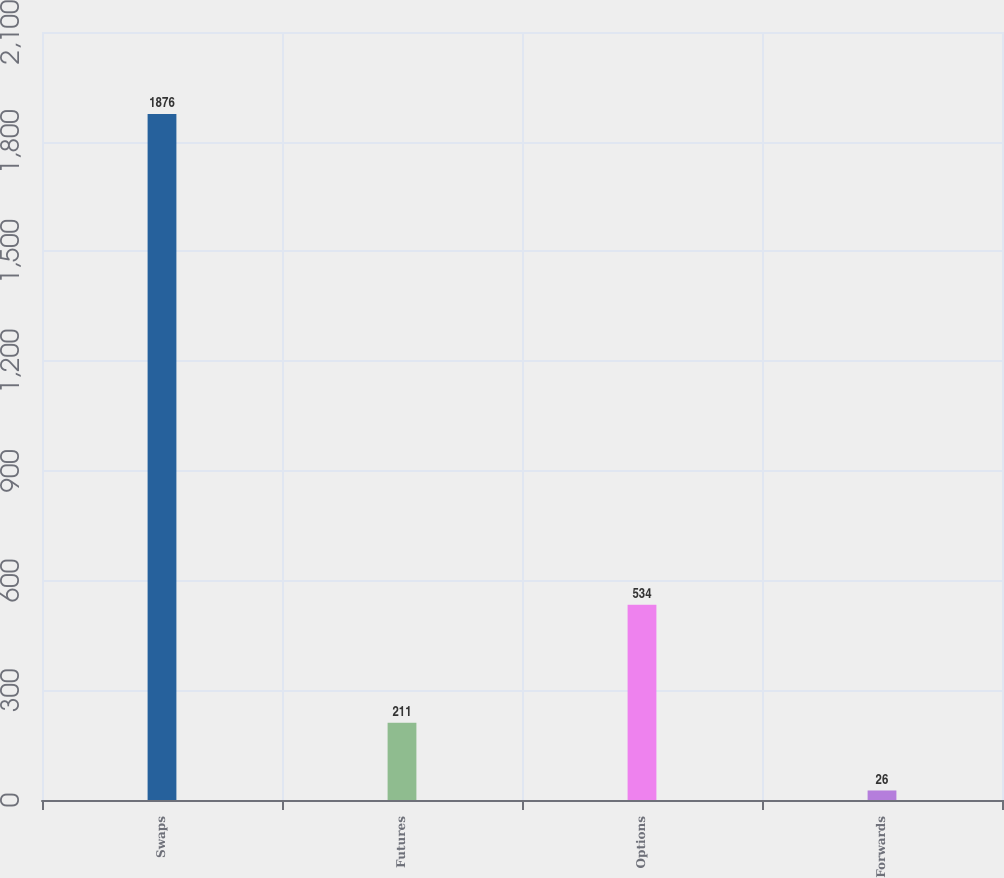Convert chart to OTSL. <chart><loc_0><loc_0><loc_500><loc_500><bar_chart><fcel>Swaps<fcel>Futures<fcel>Options<fcel>Forwards<nl><fcel>1876<fcel>211<fcel>534<fcel>26<nl></chart> 